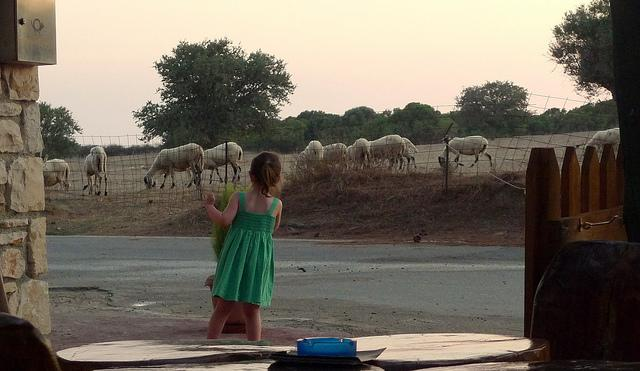What does the girl want to pet? Please explain your reasoning. sheep. The sheep are only pet in the picture. 